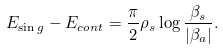<formula> <loc_0><loc_0><loc_500><loc_500>E _ { \sin g } - E _ { c o n t } = \frac { \pi } { 2 } \rho _ { s } \log \frac { \beta _ { s } } { | \beta _ { a } | } .</formula> 